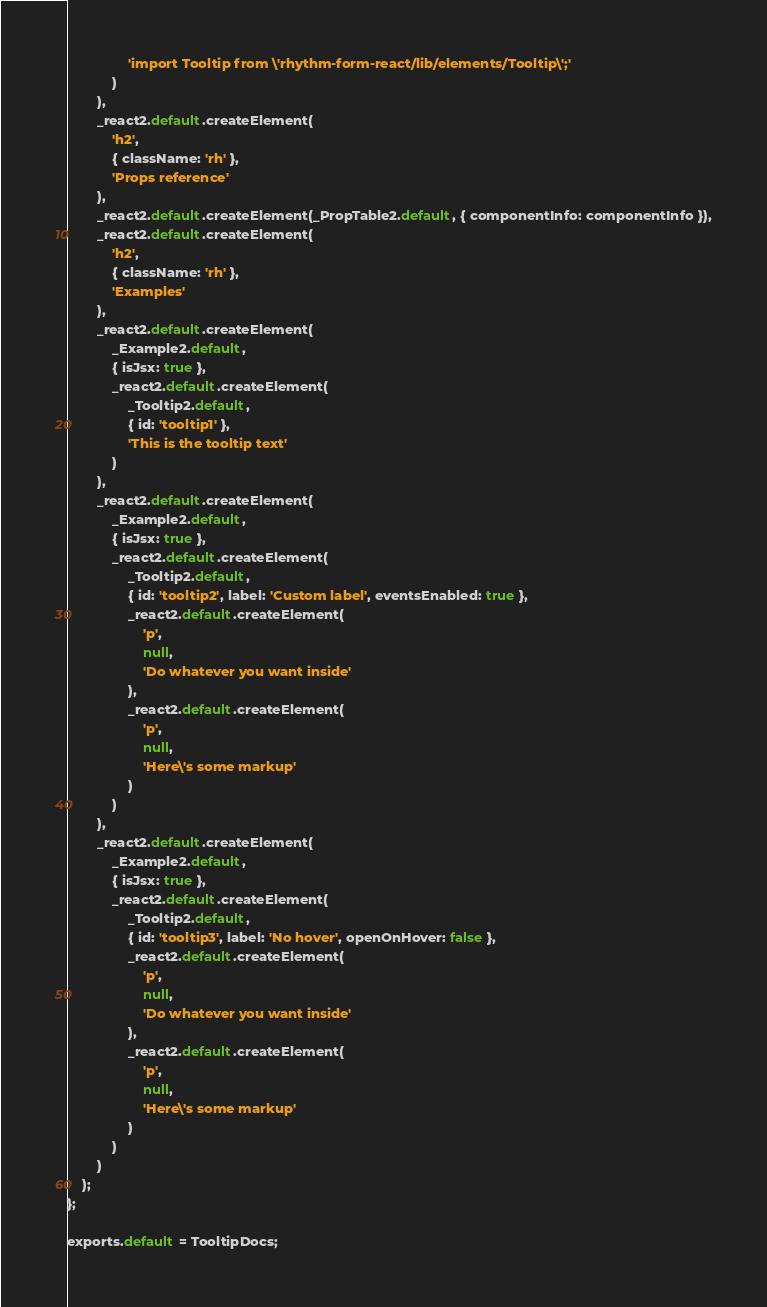<code> <loc_0><loc_0><loc_500><loc_500><_JavaScript_>				'import Tooltip from \'rhythm-form-react/lib/elements/Tooltip\';'
			)
		),
		_react2.default.createElement(
			'h2',
			{ className: 'rh' },
			'Props reference'
		),
		_react2.default.createElement(_PropTable2.default, { componentInfo: componentInfo }),
		_react2.default.createElement(
			'h2',
			{ className: 'rh' },
			'Examples'
		),
		_react2.default.createElement(
			_Example2.default,
			{ isJsx: true },
			_react2.default.createElement(
				_Tooltip2.default,
				{ id: 'tooltip1' },
				'This is the tooltip text'
			)
		),
		_react2.default.createElement(
			_Example2.default,
			{ isJsx: true },
			_react2.default.createElement(
				_Tooltip2.default,
				{ id: 'tooltip2', label: 'Custom label', eventsEnabled: true },
				_react2.default.createElement(
					'p',
					null,
					'Do whatever you want inside'
				),
				_react2.default.createElement(
					'p',
					null,
					'Here\'s some markup'
				)
			)
		),
		_react2.default.createElement(
			_Example2.default,
			{ isJsx: true },
			_react2.default.createElement(
				_Tooltip2.default,
				{ id: 'tooltip3', label: 'No hover', openOnHover: false },
				_react2.default.createElement(
					'p',
					null,
					'Do whatever you want inside'
				),
				_react2.default.createElement(
					'p',
					null,
					'Here\'s some markup'
				)
			)
		)
	);
};

exports.default = TooltipDocs;</code> 